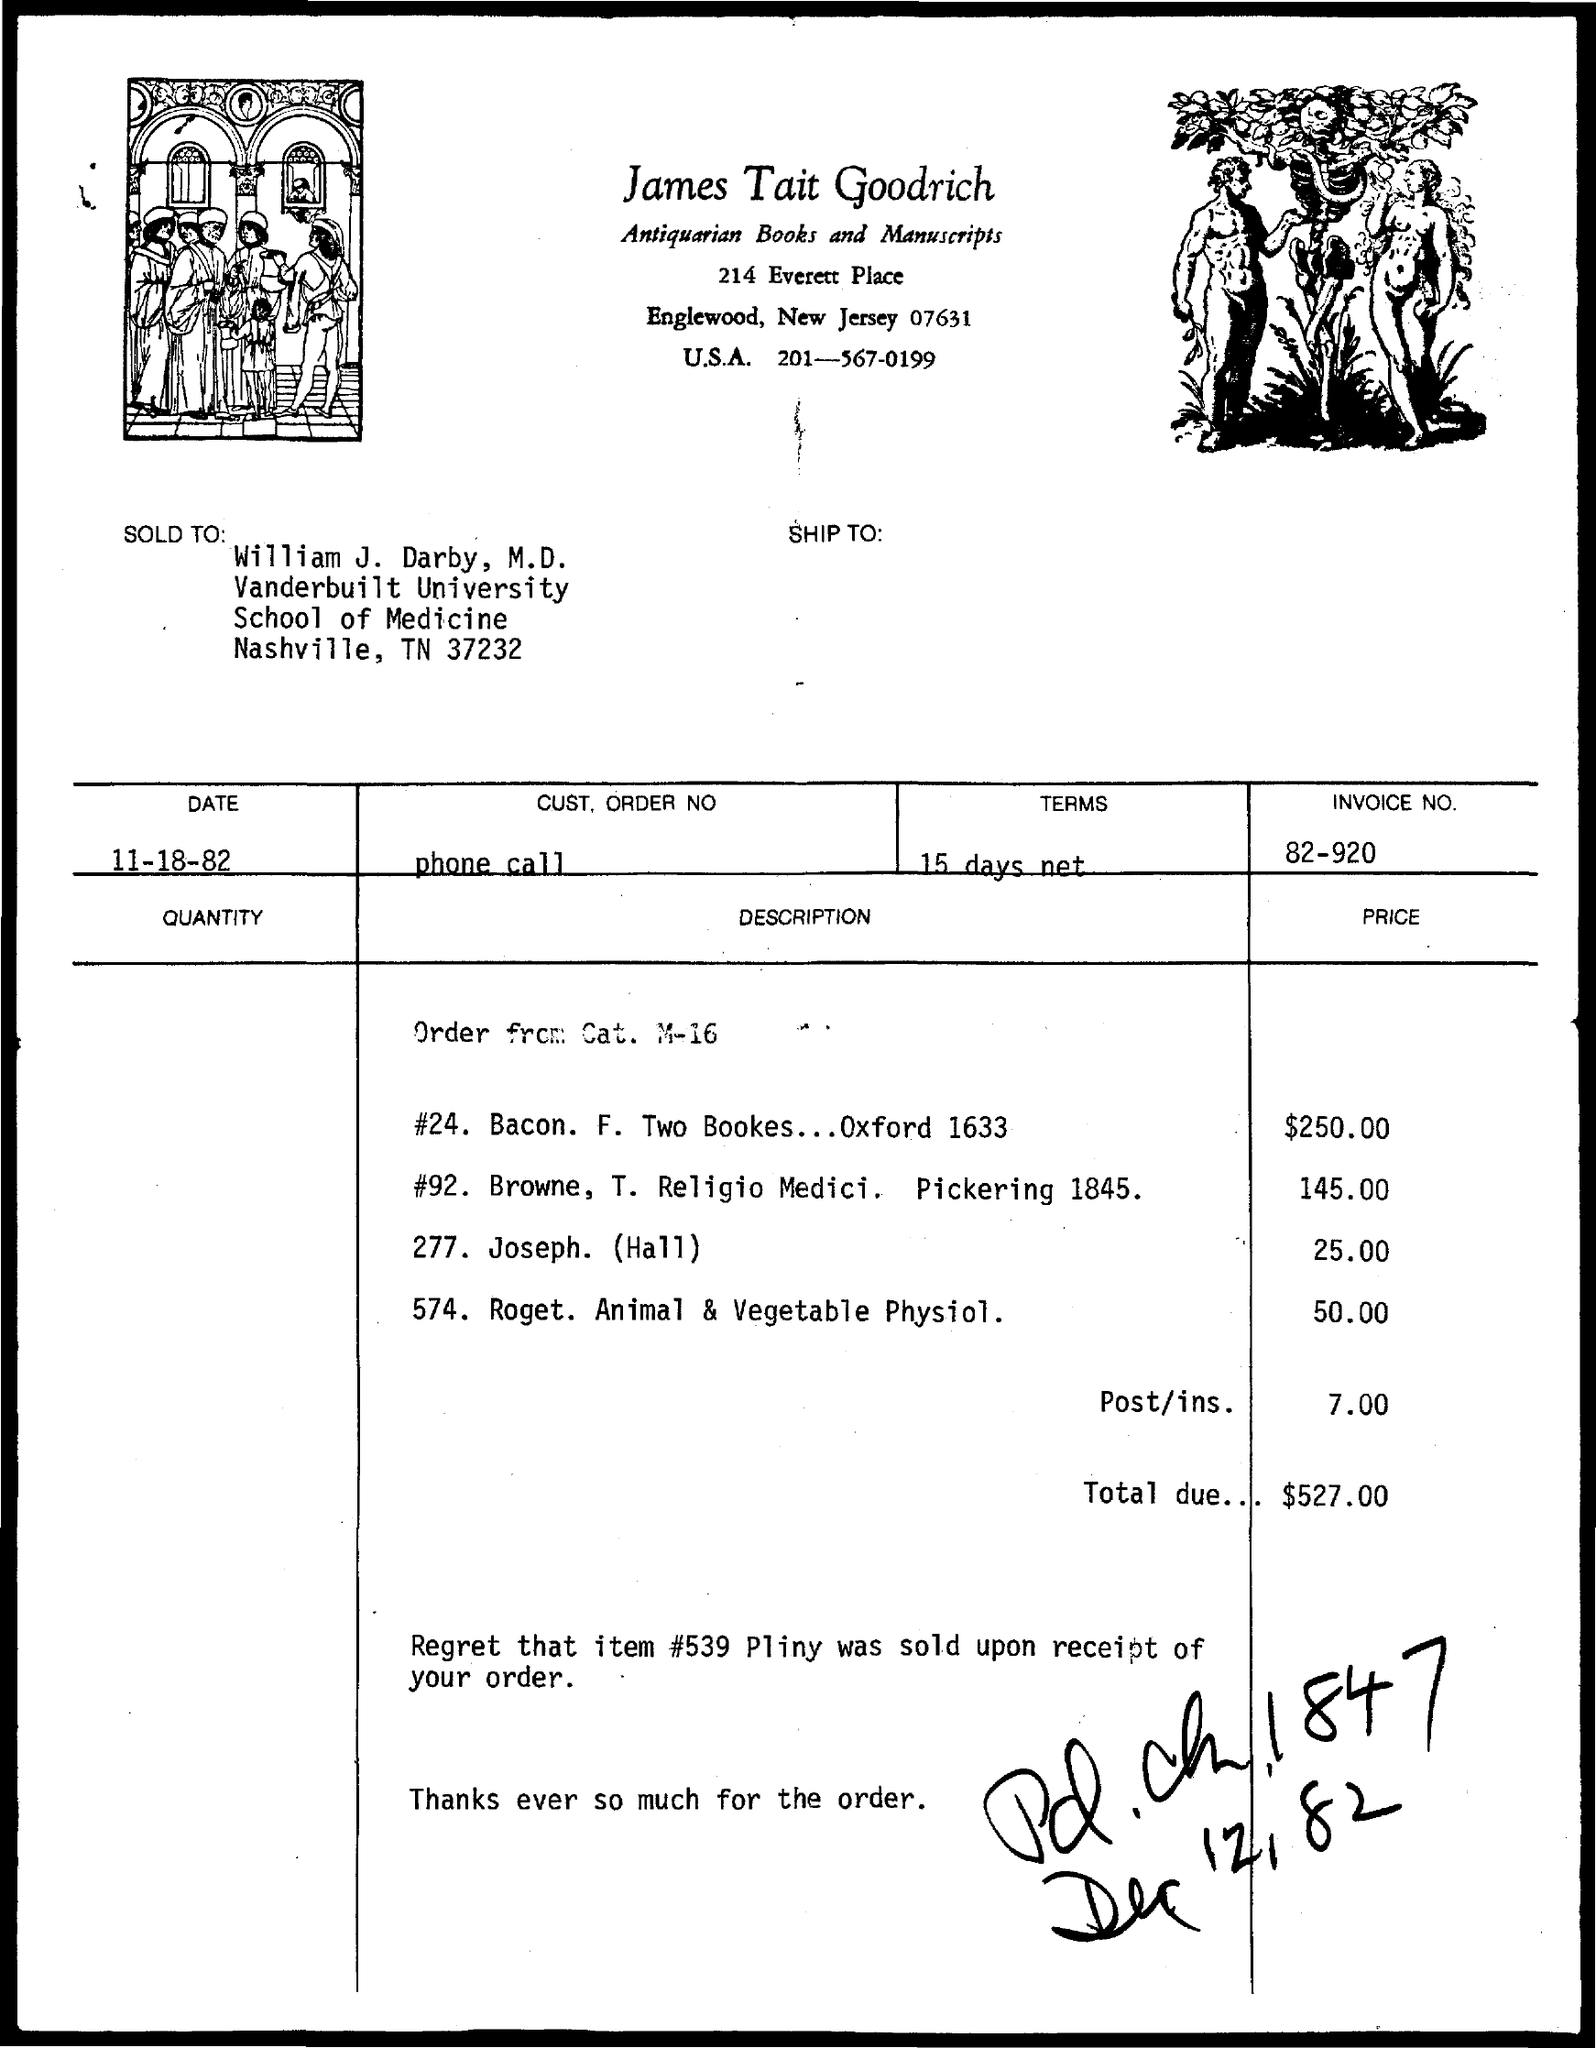What is the INVOICE number ?
Provide a short and direct response. 82-920. 